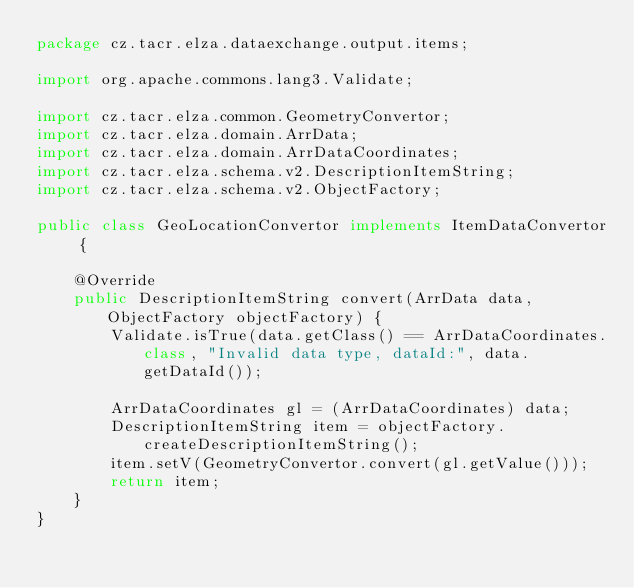<code> <loc_0><loc_0><loc_500><loc_500><_Java_>package cz.tacr.elza.dataexchange.output.items;

import org.apache.commons.lang3.Validate;

import cz.tacr.elza.common.GeometryConvertor;
import cz.tacr.elza.domain.ArrData;
import cz.tacr.elza.domain.ArrDataCoordinates;
import cz.tacr.elza.schema.v2.DescriptionItemString;
import cz.tacr.elza.schema.v2.ObjectFactory;

public class GeoLocationConvertor implements ItemDataConvertor {

    @Override
    public DescriptionItemString convert(ArrData data, ObjectFactory objectFactory) {
        Validate.isTrue(data.getClass() == ArrDataCoordinates.class, "Invalid data type, dataId:", data.getDataId());

        ArrDataCoordinates gl = (ArrDataCoordinates) data;
        DescriptionItemString item = objectFactory.createDescriptionItemString();
        item.setV(GeometryConvertor.convert(gl.getValue()));
        return item;
    }
}
</code> 